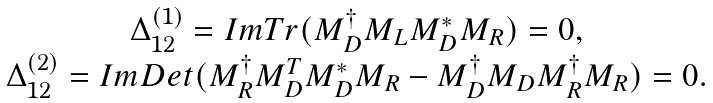<formula> <loc_0><loc_0><loc_500><loc_500>\begin{array} { c } \Delta _ { 1 2 } ^ { ( 1 ) } = I m T r ( M _ { D } ^ { \dagger } M _ { L } M _ { D } ^ { * } M _ { R } ) = 0 , \\ \Delta _ { 1 2 } ^ { ( 2 ) } = I m D e t ( M _ { R } ^ { \dagger } M _ { D } ^ { T } M _ { D } ^ { * } M _ { R } - M _ { D } ^ { \dagger } M _ { D } M _ { R } ^ { \dagger } M _ { R } ) = 0 . \end{array}</formula> 